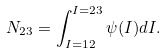<formula> <loc_0><loc_0><loc_500><loc_500>N _ { 2 3 } = \int _ { I = 1 2 } ^ { I = 2 3 } \psi ( I ) d I .</formula> 